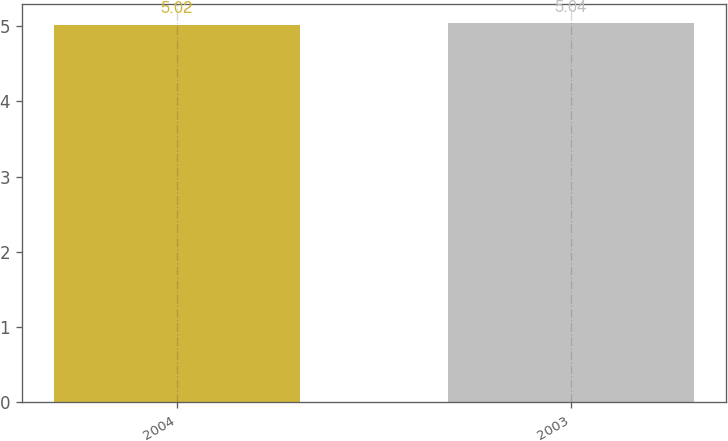<chart> <loc_0><loc_0><loc_500><loc_500><bar_chart><fcel>2004<fcel>2003<nl><fcel>5.02<fcel>5.04<nl></chart> 